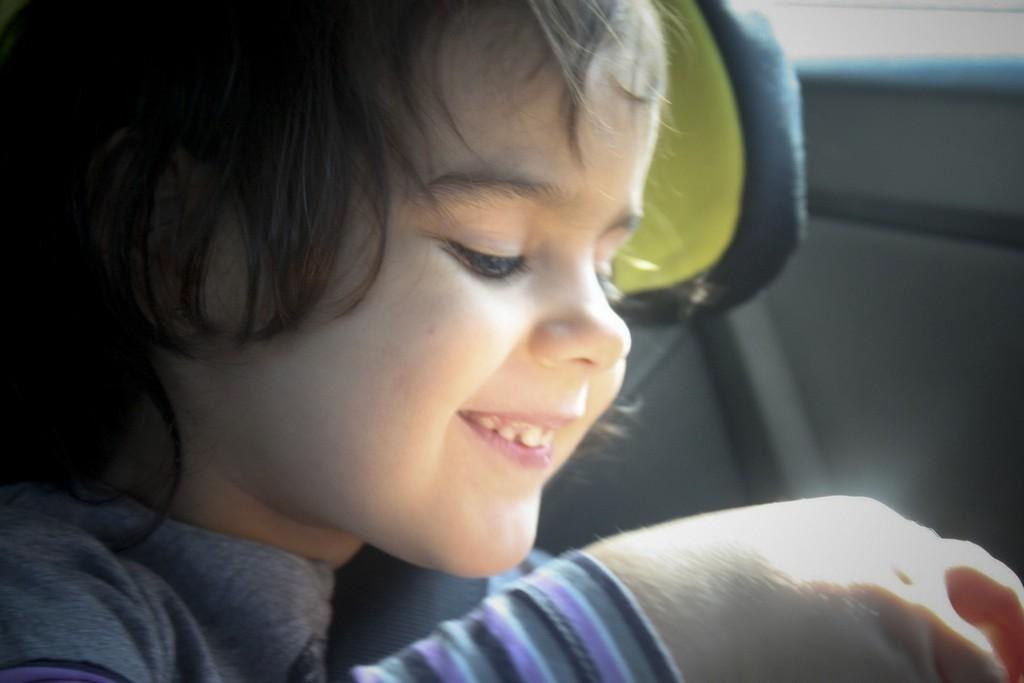What is the main subject of the image? The main subject of the image is a kid. What is the kid doing in the image? The kid is smiling in the image. Can you describe anything in the background of the image? There is an object in the background of the image. What type of stone is the kid adjusting in the image? There is no stone present in the image, nor is the kid adjusting anything. 